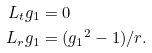Convert formula to latex. <formula><loc_0><loc_0><loc_500><loc_500>L _ { t } g _ { 1 } & = 0 \\ L _ { r } g _ { 1 } & = ( { g _ { 1 } } ^ { 2 } - 1 ) / r .</formula> 